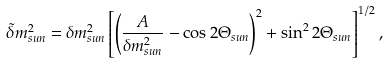<formula> <loc_0><loc_0><loc_500><loc_500>\tilde { \delta } m ^ { 2 } _ { s u n } = \delta m ^ { 2 } _ { s u n } \left [ \left ( \frac { A } { \delta m ^ { 2 } _ { s u n } } - \cos { 2 \Theta _ { s u n } } \right ) ^ { 2 } + \sin ^ { 2 } { 2 { \Theta } _ { s u n } } \right ] ^ { 1 / 2 } ,</formula> 